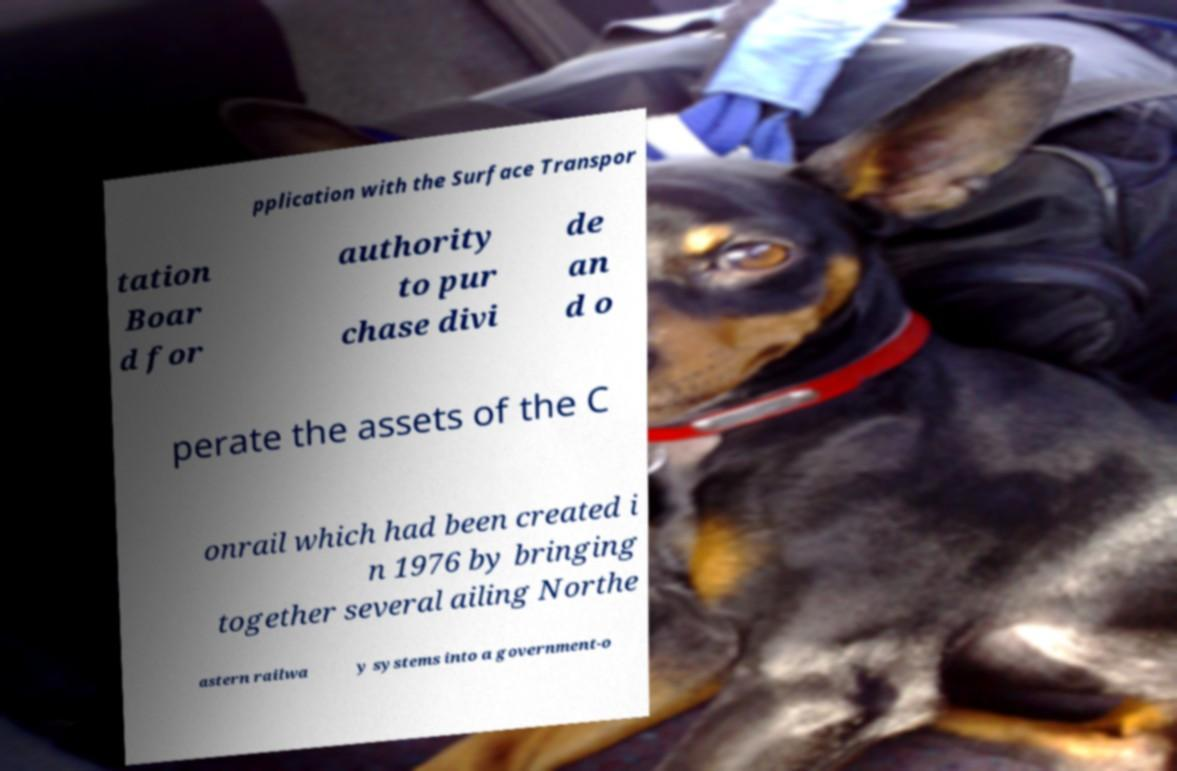Can you accurately transcribe the text from the provided image for me? pplication with the Surface Transpor tation Boar d for authority to pur chase divi de an d o perate the assets of the C onrail which had been created i n 1976 by bringing together several ailing Northe astern railwa y systems into a government-o 